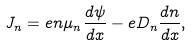<formula> <loc_0><loc_0><loc_500><loc_500>J _ { n } = e n \mu _ { n } \frac { d \psi } { d x } - e D _ { n } \frac { d n } { d x } , \\</formula> 